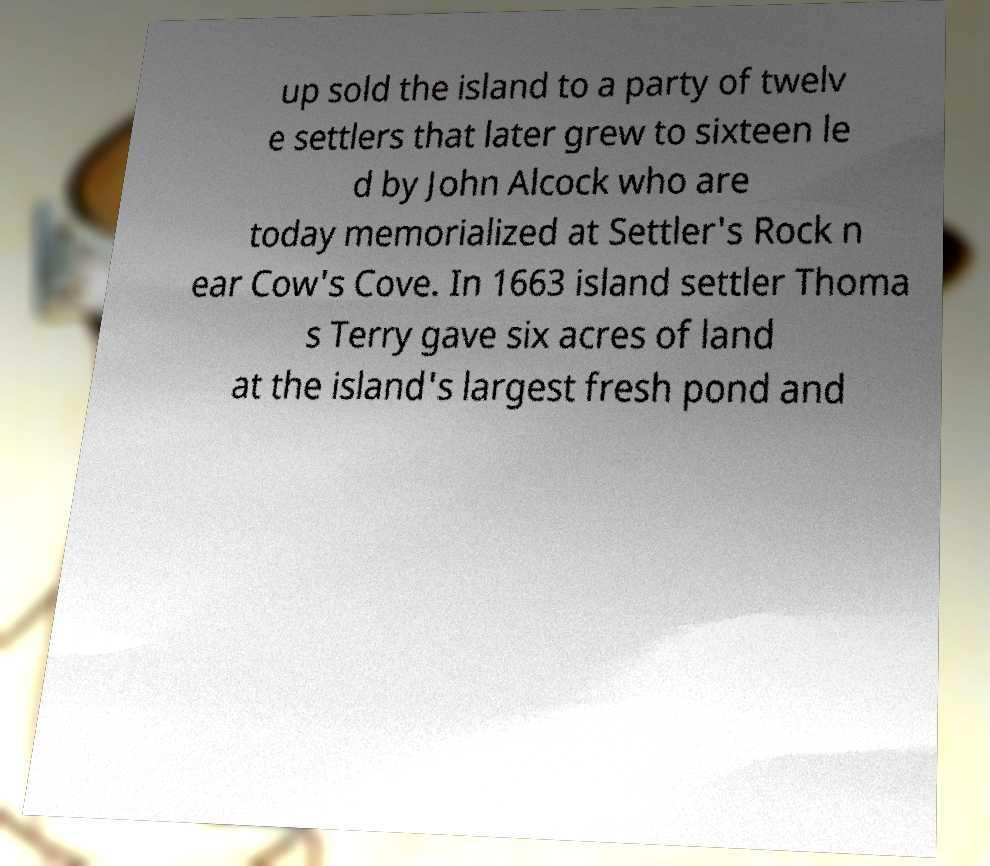Please read and relay the text visible in this image. What does it say? up sold the island to a party of twelv e settlers that later grew to sixteen le d by John Alcock who are today memorialized at Settler's Rock n ear Cow's Cove. In 1663 island settler Thoma s Terry gave six acres of land at the island's largest fresh pond and 